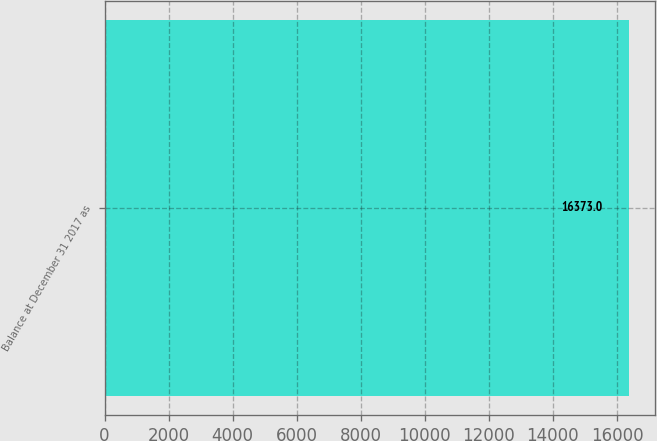Convert chart to OTSL. <chart><loc_0><loc_0><loc_500><loc_500><bar_chart><fcel>Balance at December 31 2017 as<nl><fcel>16373<nl></chart> 